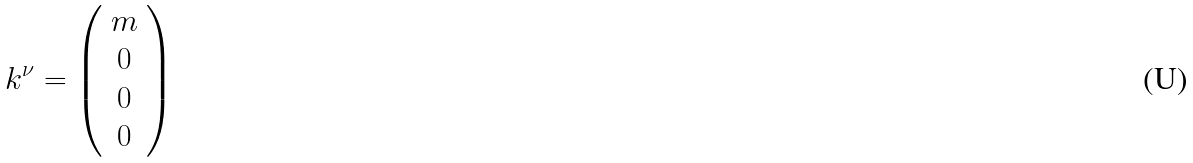<formula> <loc_0><loc_0><loc_500><loc_500>k ^ { \nu } = \left ( \begin{array} { c } { m } \\ { 0 } \\ { 0 } \\ { 0 } \end{array} \right )</formula> 